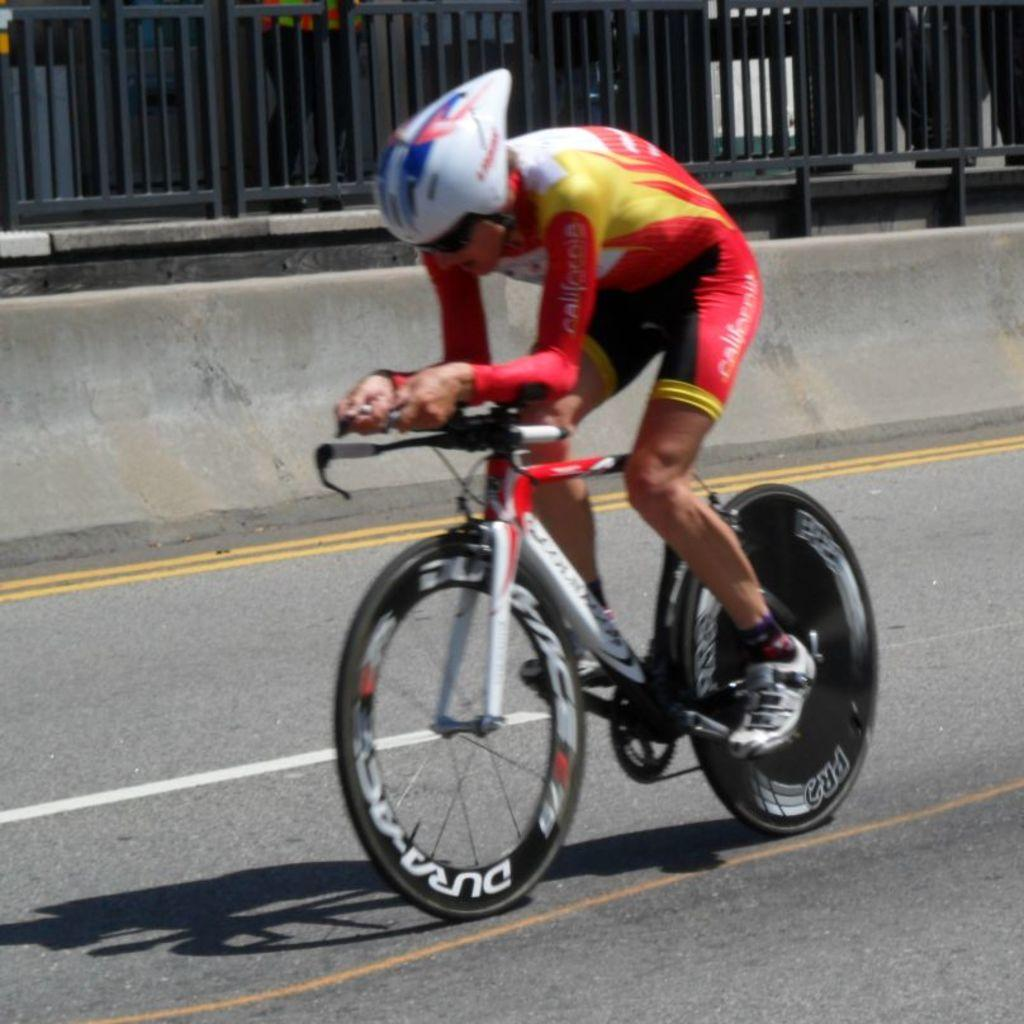What is the person in the image doing? The person is riding a bicycle in the image. What is the person wearing while riding the bicycle? The person is wearing a helmet. Where is the bicycle located? The bicycle is on a road. What structures can be seen in the image? There is a fence and a wall in the image. What type of powder is being used by the woman in the image? There is no woman present in the image, and no powder is being used. 